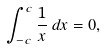<formula> <loc_0><loc_0><loc_500><loc_500>\int _ { - c } ^ { c } { \frac { 1 } { x } } \, d x = 0 ,</formula> 